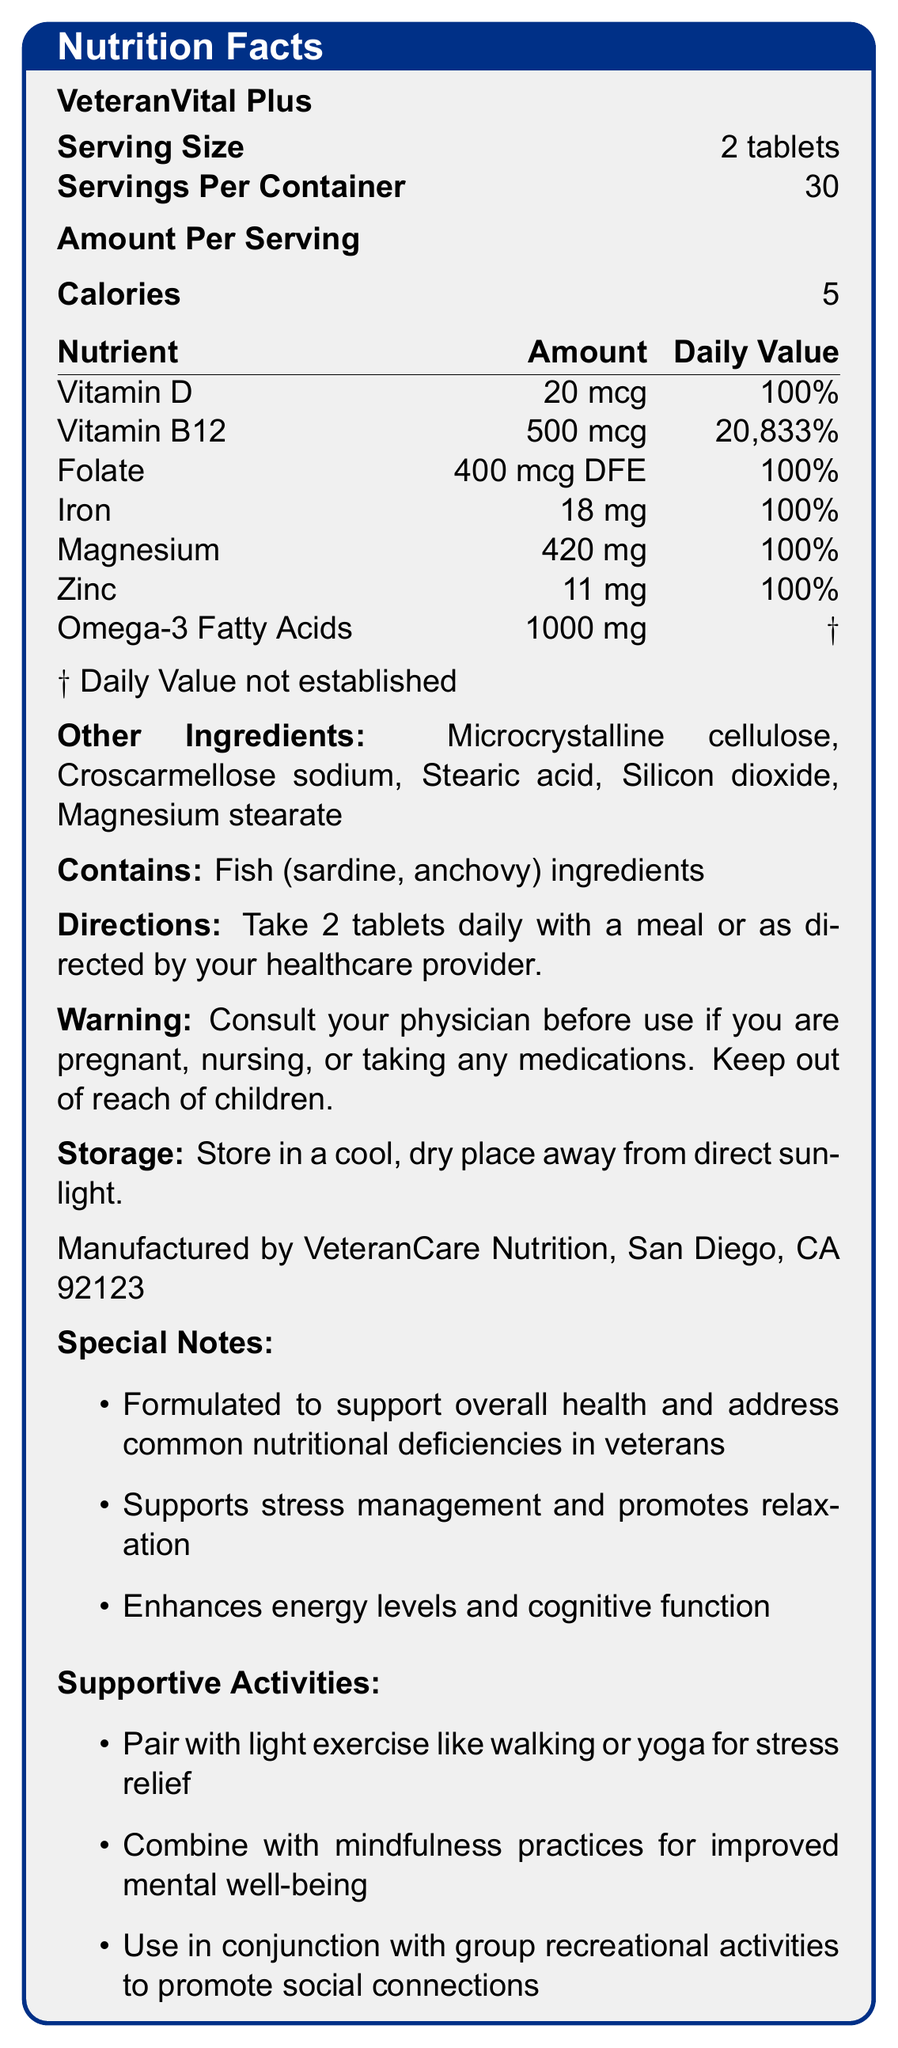what is the serving size for VeteranVital Plus? The document states that the serving size is 2 tablets.
Answer: 2 tablets how many servings are there per container? The document specifies that there are 30 servings per container.
Answer: 30 how many calories are in each serving? The document mentions that each serving has 5 calories.
Answer: 5 what is the amount of Vitamin D per serving? The document lists Vitamin D as having 20 mcg per serving.
Answer: 20 mcg what is the percentage of daily value for Iron in one serving? The nutrient table in the document shows that the daily value for Iron is 100%.
Answer: 100% what are the other ingredients in VeteranVital Plus? The document lists these ingredients under "Other Ingredients."
Answer: Microcrystalline cellulose, Croscarmellose sodium, Stearic acid, Silicon dioxide, Magnesium stearate what allergens are contained in VeteranVital Plus? A) Dairy B) Fish C) Soy D) Nuts The document states that the product contains fish ingredients (sardine, anchovy).
Answer: B) Fish how much Vitamin B12 is in each serving? A) 100 mcg B) 500 mcg C) 1000 mcg D) 200 mcg The document lists the amount of Vitamin B12 as 500 mcg per serving.
Answer: B) 500 mcg does VeteranVital Plus contain Omega-3 Fatty Acids? (Yes/No) The document lists Omega-3 Fatty Acids as one of the nutrients.
Answer: Yes is the percentage daily value for Omega-3 Fatty Acids established? The document notes that the daily value for Omega-3 Fatty Acids is not established, as indicated by "†".
Answer: No what directions are given for taking VeteranVital Plus? The directions are clearly stated in the document.
Answer: Take 2 tablets daily with a meal or as directed by your healthcare provider what warnings are provided in the document? The warning section of the document provides this information.
Answer: Consult your physician before use if you are pregnant, nursing, or taking any medications. Keep out of reach of children. where should VeteranVital Plus be stored? The document gives storage instructions indicating to store the supplement in a cool, dry place away from direct sunlight.
Answer: In a cool, dry place away from direct sunlight what special notes are included about VeteranVital Plus? The document includes several special notes such as supporting overall health and addressing common nutritional deficiencies in veterans.
Answer: Formulated to support overall health and address common nutritional deficiencies in veterans what supportive activities are recommended when using VeteranVital Plus? A) Light exercise B) Yoga C) Group activities D) All of the above The document lists all these supportive activities: light exercise, yoga, and group recreational activities.
Answer: D) All of the above what is the main idea of the document? The document centralizes around describing the aspects of VeteranVital Plus, including its nutritional value, ingredients, directions for use, and supportive activities for better health.
Answer: The document provides detailed nutrition information, ingredients, directions, and additional notes about VeteranVital Plus, a vitamin supplement formulated to support veterans' health and well-being. does the document mention how VeteranVital Plus enhances energy levels and cognitive function? The special notes section of the document mentions that the supplement enhances energy levels and cognitive function.
Answer: Yes what is the contact information for the manufacturer? The document states the manufacturer's information: VeteranCare Nutrition, San Diego, CA 92123.
Answer: Manufactured by VeteranCare Nutrition, San Diego, CA 92123 what medications can interact with VeteranVital Plus? The document advises consulting a physician if taking medications but does not specify which medications could interact with the supplement.
Answer: Cannot be determined 